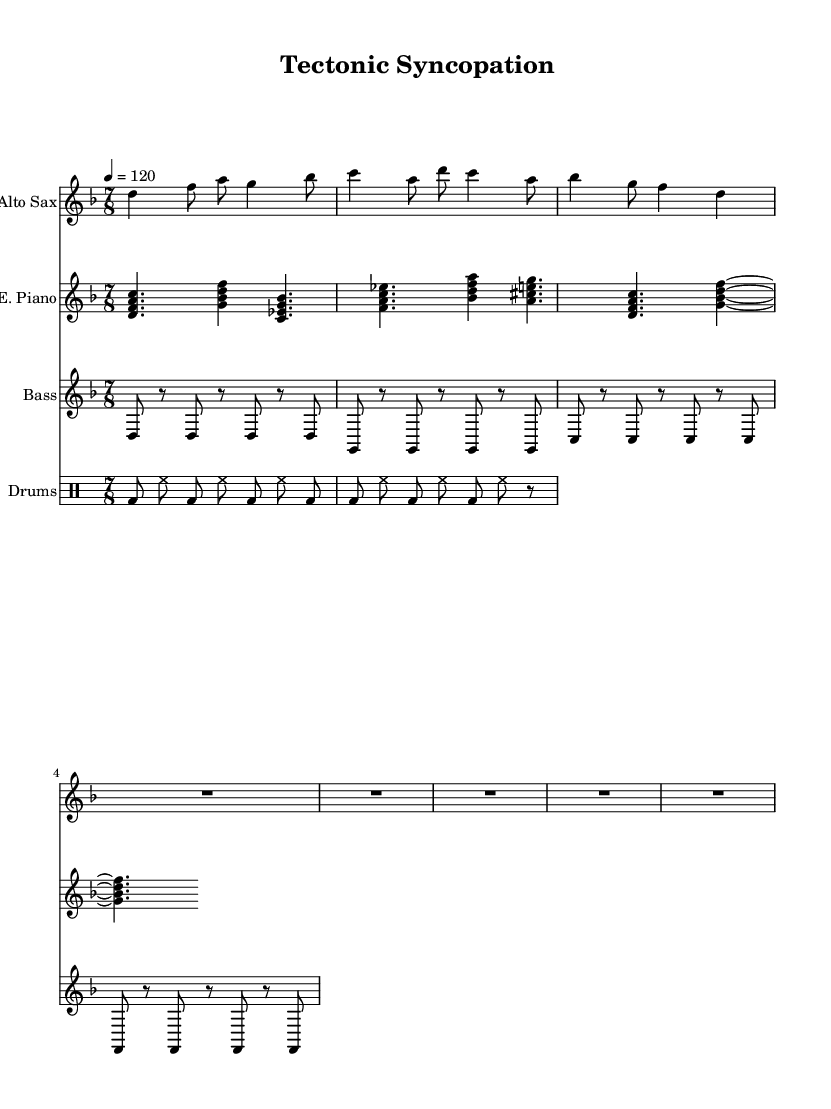What is the key signature of this music? The key signature is indicated at the beginning of the staff and shows that the music is in the key of D minor, which has one flat.
Answer: D minor What is the time signature of this music? The time signature appears at the beginning and indicates the pattern of beats in a measure; here it is 7/8, meaning there are seven eighth notes per measure.
Answer: 7/8 What is the tempo marking for this piece? The tempo marking is located next to the time signature and indicates the speed of the piece; it states "4 = 120," meaning there are 120 quarter note beats per minute.
Answer: 120 How many measures does the saxophone part contain before the improvisation? By counting the visible measures in the saxophone music staff before the placeholder for improvisation (R1*7/8*5), there are 3 complete measures shown.
Answer: 3 Which instrument plays the chords? The instrument staff that shows filled note heads indicating harmonies or chords is the electric piano part which plays groupings of notes together.
Answer: Electric Piano What rhythmic pattern is predominantly used by the bass? By examining the bass staff, it becomes clear that the pattern consists of alternating single notes and rests, primarily focusing on eighth notes in a repetitive sequence.
Answer: Alternating single notes and rests What fusion elements are represented in the drum part? The drum part incorporates a mix of bass drum and hi-hat patterns that contribute to a rhythmic complexity often found in jazz while maintaining the structure of the underlying groove.
Answer: Bass drum and hi-hat patterns 